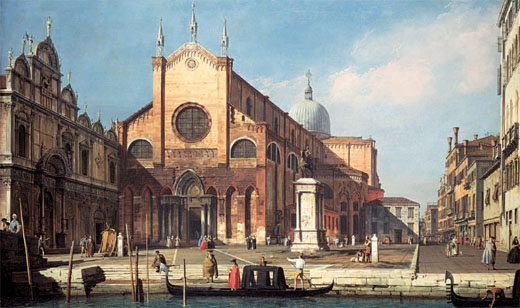What stories might the people in the foreground be telling? In the foreground of this captivating Venetian scene, people are seen engaging in various activities, each telling their own unique story. A group of merchants might be discussing the latest trade goods arriving from distant lands, eagerly sharing news about exotic spices or luxurious fabrics. Nearby, a family perhaps converses about their daily life, planning their activities for the day or sharing anecdotes about recent events in the city. Children, with eyes full of wonder, may be excitedly talking about the vibrant festivities they witnessed at the local carnival. Gondoliers, preparing their boats for tourists, might exchange tips on the best routes to showcase the city's beauty. Each individual contributes to the rich tapestry of life in Venice, their stories blending together to create a dynamic, living narrative of the city. 